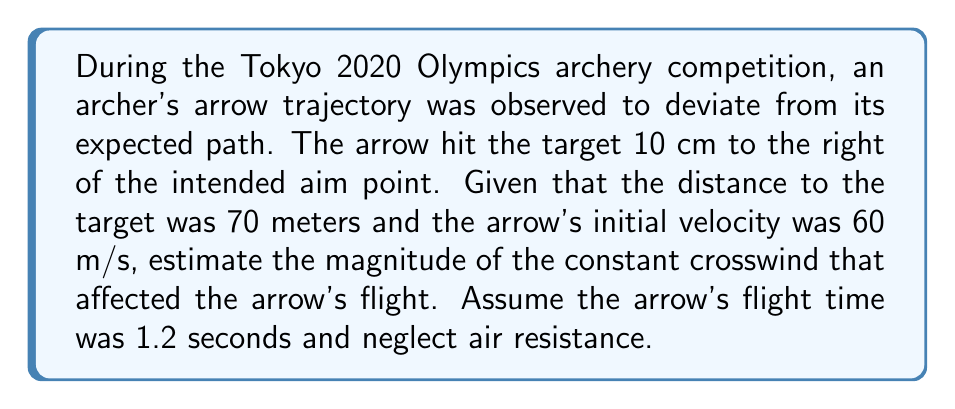Teach me how to tackle this problem. To solve this inverse problem, we'll use the equations of motion for projectile motion with a constant crosswind:

1. The lateral displacement due to wind is given by:
   $$x = \frac{1}{2}at^2$$
   where $x$ is the displacement, $a$ is the acceleration due to wind, and $t$ is the flight time.

2. The acceleration due to wind can be expressed as:
   $$a = \frac{F}{m} = \frac{\frac{1}{2}\rho C_d A v_w^2}{m}$$
   where $\rho$ is air density, $C_d$ is the drag coefficient, $A$ is the arrow's cross-sectional area, $v_w$ is wind velocity, and $m$ is the arrow's mass.

3. We know the lateral displacement $x = 0.10$ m and the flight time $t = 1.2$ s. Substituting these into the first equation:
   $$0.10 = \frac{1}{2}a(1.2)^2$$
   $$a = \frac{2 \times 0.10}{1.2^2} = 0.139 \text{ m/s}^2$$

4. Now, we need to solve for $v_w$ in the second equation. However, we don't have all the necessary information about the arrow's properties. In practice, these would be known or measured.

5. For the purpose of this problem, let's assume typical values:
   $\rho = 1.225 \text{ kg/m}^3$ (air density at sea level)
   $C_d = 0.5$ (approximate drag coefficient for an arrow)
   $A = 5 \times 10^{-4} \text{ m}^2$ (cross-sectional area of an arrow)
   $m = 0.02 \text{ kg}$ (mass of an Olympic arrow)

6. Substituting these values and solving for $v_w$:
   $$0.139 = \frac{\frac{1}{2} \times 1.225 \times 0.5 \times 5 \times 10^{-4} \times v_w^2}{0.02}$$
   $$v_w^2 = \frac{2 \times 0.139 \times 0.02}{1.225 \times 0.5 \times 5 \times 10^{-4}} = 1813.88$$
   $$v_w = \sqrt{1813.88} = 42.59 \text{ m/s}$$

Therefore, the estimated crosswind velocity is approximately 42.59 m/s or 153 km/h.
Answer: 42.59 m/s 